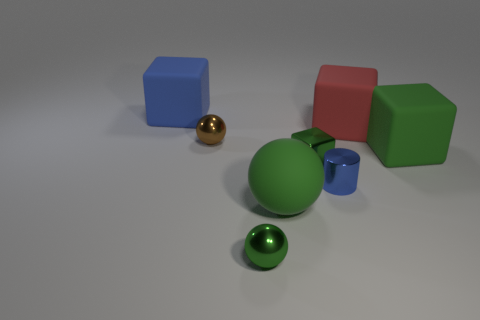What number of green objects are to the left of the brown metal sphere?
Your answer should be compact. 0. Do the big block left of the red matte thing and the green block to the left of the red matte thing have the same material?
Keep it short and to the point. No. Is the number of balls that are to the right of the large blue matte thing greater than the number of small metal cylinders in front of the blue metallic cylinder?
Offer a very short reply. Yes. There is a big object that is the same color as the big rubber sphere; what is its material?
Offer a terse response. Rubber. Are there any other things that are the same shape as the small blue thing?
Your response must be concise. No. What is the thing that is both left of the red matte thing and behind the tiny brown sphere made of?
Keep it short and to the point. Rubber. Are the tiny blue thing and the green block that is in front of the large green block made of the same material?
Offer a terse response. Yes. How many objects are large cyan rubber spheres or blocks that are on the right side of the blue rubber cube?
Provide a short and direct response. 3. There is a green matte thing that is behind the tiny blue shiny cylinder; is it the same size as the blue object that is in front of the red thing?
Your response must be concise. No. What number of other objects are the same color as the metallic block?
Give a very brief answer. 3. 